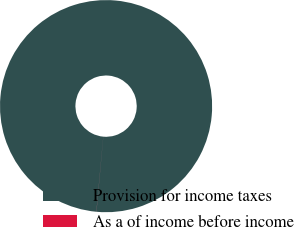Convert chart. <chart><loc_0><loc_0><loc_500><loc_500><pie_chart><fcel>Provision for income taxes<fcel>As a of income before income<nl><fcel>99.99%<fcel>0.01%<nl></chart> 